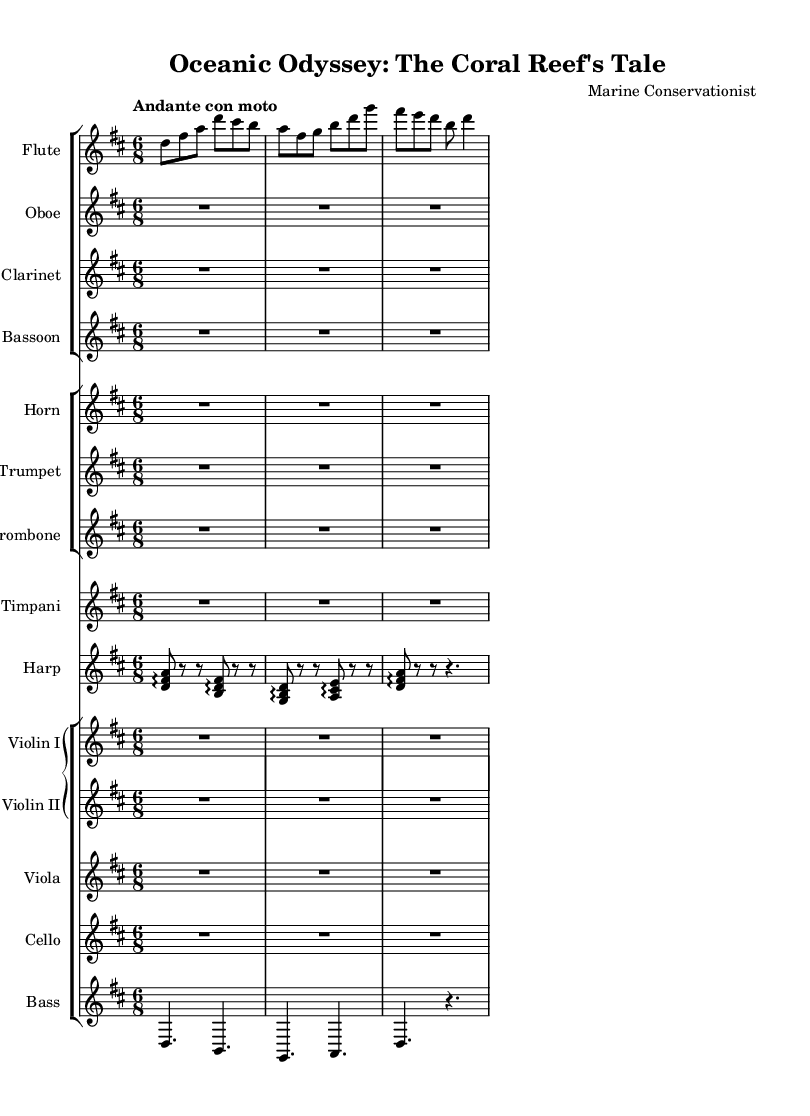What is the key signature of this music? The key signature is indicated at the beginning of the score and shows two sharps, which correspond to F# and C#. This means it is in D major.
Answer: D major What is the time signature of this music? The time signature is shown at the beginning of the score. It is written as 6/8, indicating that there are six eighth notes per measure.
Answer: 6/8 What is the tempo marking in this score? The tempo marking, shown at the beginning of the score, reads "Andante con moto," which indicates a moderate tempo with a bit of motion.
Answer: Andante con moto How many instrumental sections are there in the composition? The score consists of three main groups of instruments: woodwinds, brass, and strings. Counting these groups shows that there are multiple instruments within these sections.
Answer: Three In which instrument group is the harp found? At the beginning of the score, the harp is listed in the piano staff which is separate from the string and wind groups, indicating it is part of the orchestral arrangement.
Answer: Piano staff What type of musical piece is this? The title of the score is "Oceanic Odyssey: The Coral Reef's Tale" and it is presented as a symphony, specifically depicting the life cycle of marine species. This categorizes it as an orchestral work.
Answer: Symphony How is dynamics represented in this piece? The dynamics are typically indicated by symbols that are placed under or above the staff in the score but are not explicitly listed here. Thus, one could explore the way lines are arranged for dynamics in orchestral music.
Answer: Not specified 